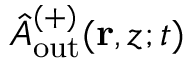Convert formula to latex. <formula><loc_0><loc_0><loc_500><loc_500>\hat { A } _ { o u t } ^ { ( + ) } ( r , z ; t )</formula> 